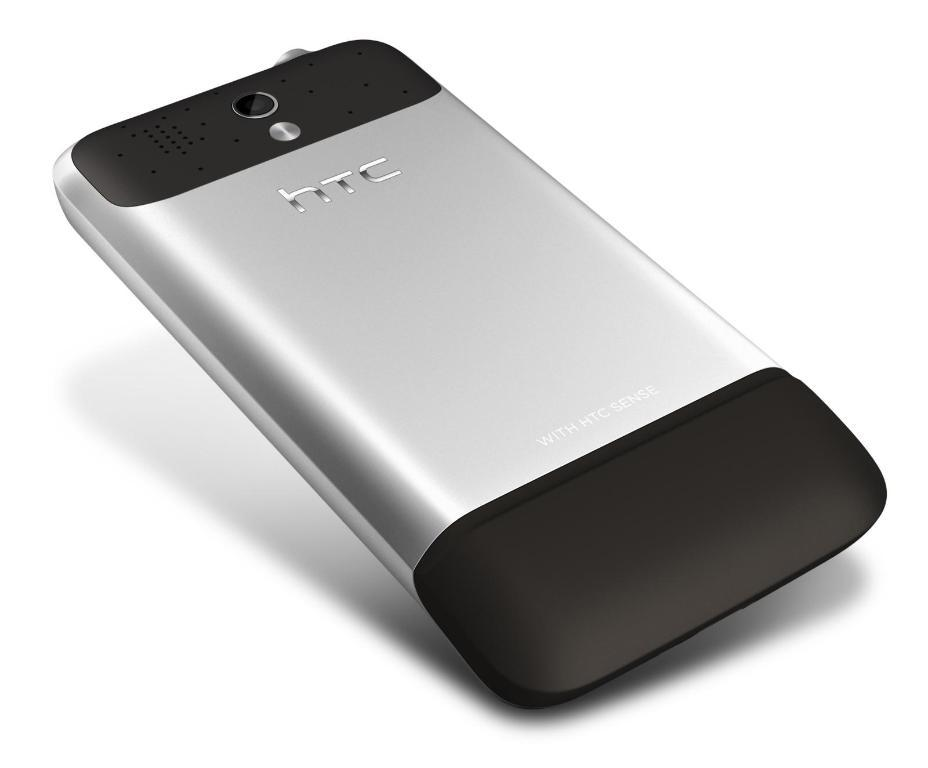<image>
Relay a brief, clear account of the picture shown. the back of a black and silver htc phone 